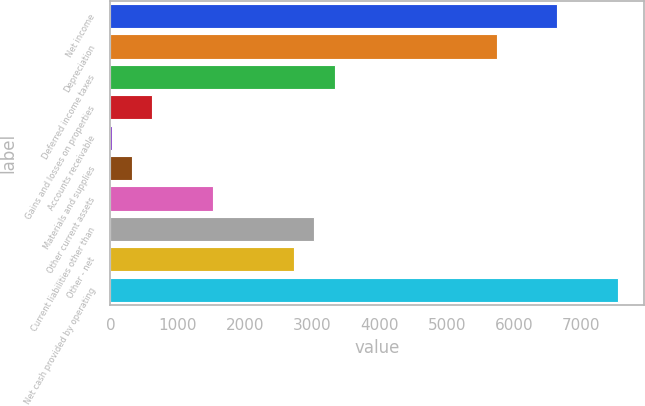Convert chart. <chart><loc_0><loc_0><loc_500><loc_500><bar_chart><fcel>Net income<fcel>Depreciation<fcel>Deferred income taxes<fcel>Gains and losses on properties<fcel>Accounts receivable<fcel>Materials and supplies<fcel>Other current assets<fcel>Current liabilities other than<fcel>Other - net<fcel>Net cash provided by operating<nl><fcel>6647.2<fcel>5743.9<fcel>3335.1<fcel>625.2<fcel>23<fcel>324.1<fcel>1528.5<fcel>3034<fcel>2732.9<fcel>7550.5<nl></chart> 